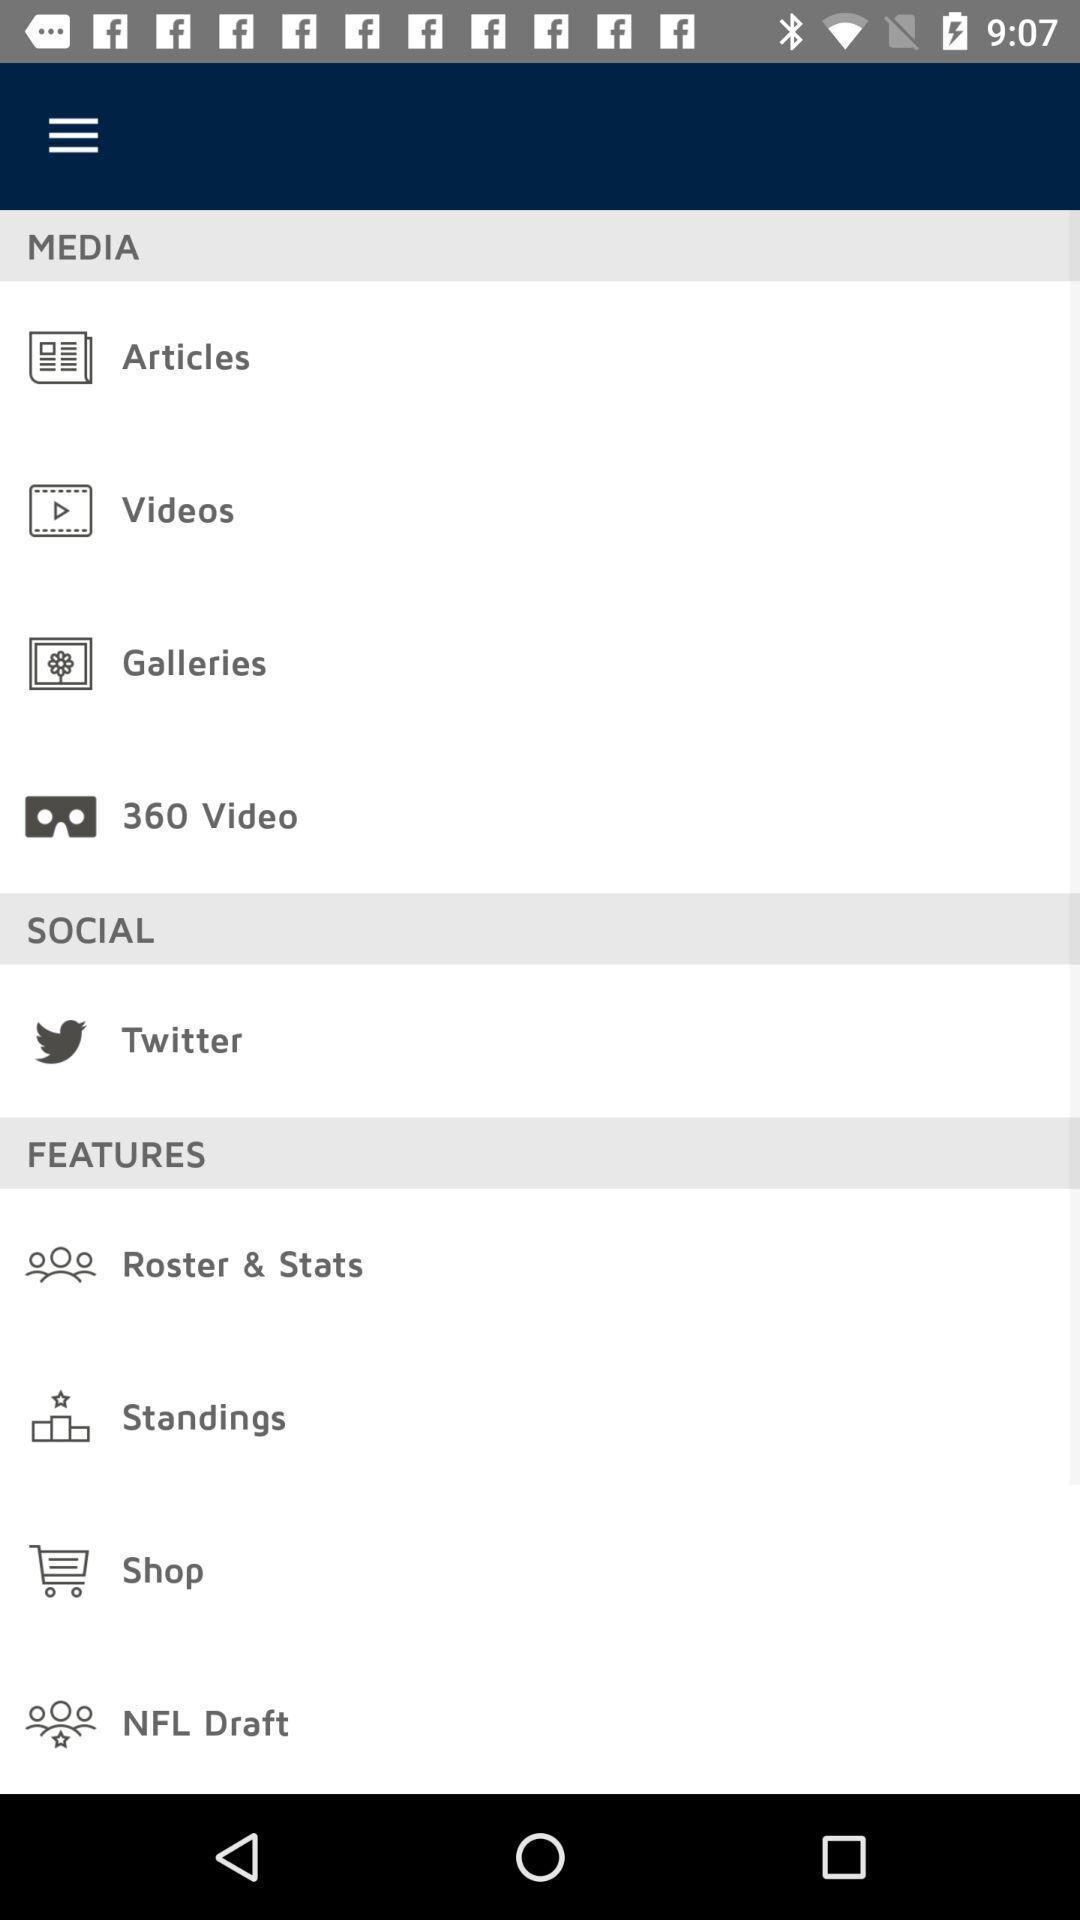What can you discern from this picture? Various categories in a gaming app. 